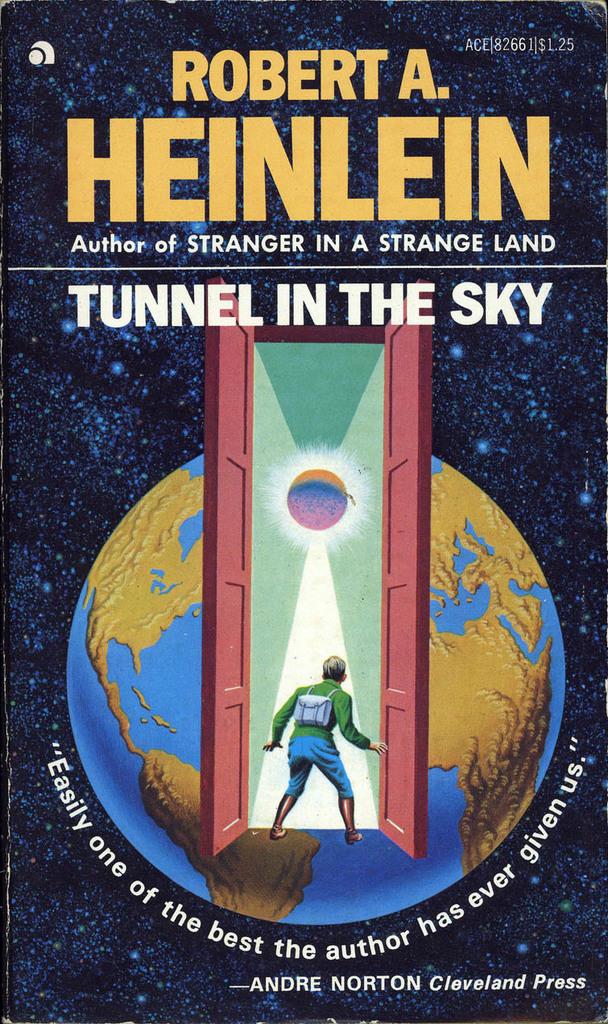Who wrote this book?
Offer a very short reply. Robert a. heinlein. 